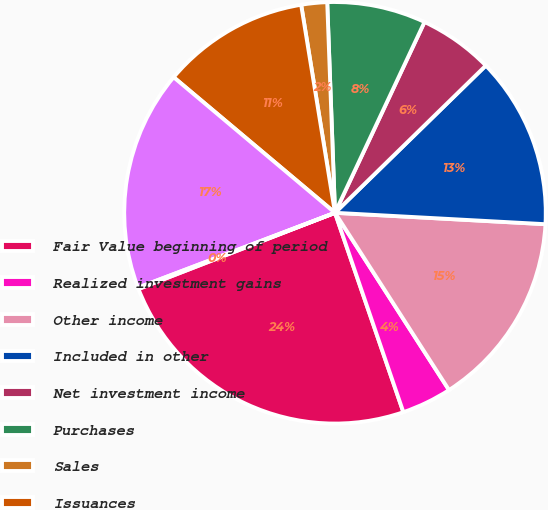Convert chart to OTSL. <chart><loc_0><loc_0><loc_500><loc_500><pie_chart><fcel>Fair Value beginning of period<fcel>Realized investment gains<fcel>Other income<fcel>Included in other<fcel>Net investment income<fcel>Purchases<fcel>Sales<fcel>Issuances<fcel>Settlements<fcel>Foreign currency translation<nl><fcel>24.37%<fcel>3.84%<fcel>15.04%<fcel>13.17%<fcel>5.71%<fcel>7.57%<fcel>1.98%<fcel>11.31%<fcel>16.9%<fcel>0.11%<nl></chart> 